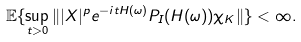<formula> <loc_0><loc_0><loc_500><loc_500>\mathbb { E } \{ \sup _ { t > 0 } \| | X | ^ { p } e ^ { - i t H ( \omega ) } P _ { I } ( H ( \omega ) ) \chi _ { K } \| \} < \infty .</formula> 